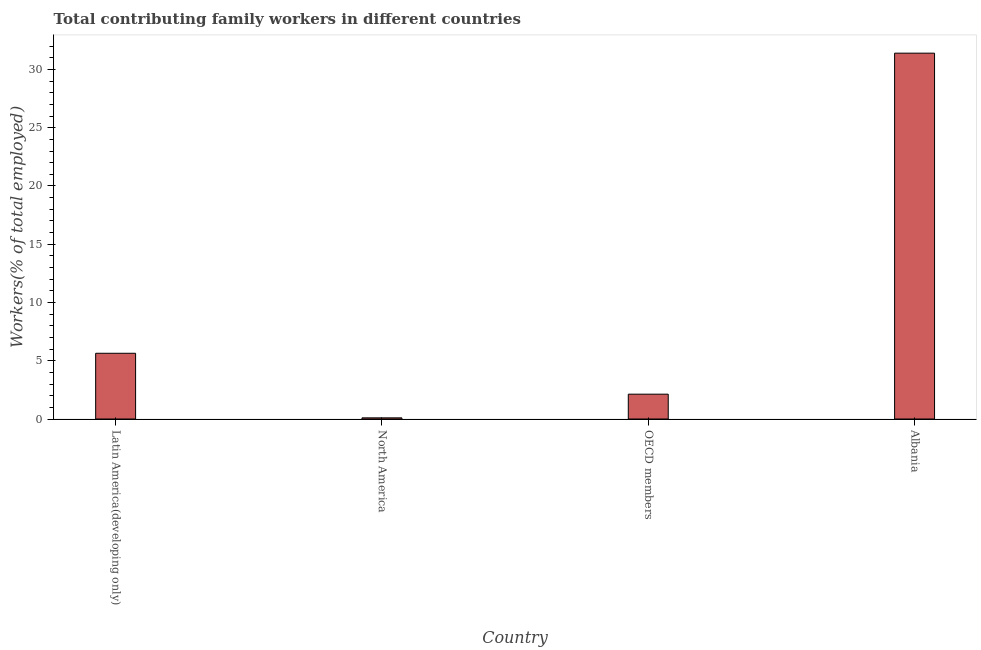What is the title of the graph?
Keep it short and to the point. Total contributing family workers in different countries. What is the label or title of the X-axis?
Provide a short and direct response. Country. What is the label or title of the Y-axis?
Give a very brief answer. Workers(% of total employed). What is the contributing family workers in Latin America(developing only)?
Offer a terse response. 5.64. Across all countries, what is the maximum contributing family workers?
Provide a short and direct response. 31.4. Across all countries, what is the minimum contributing family workers?
Your response must be concise. 0.1. In which country was the contributing family workers maximum?
Offer a very short reply. Albania. What is the sum of the contributing family workers?
Make the answer very short. 39.27. What is the difference between the contributing family workers in Latin America(developing only) and OECD members?
Your answer should be compact. 3.51. What is the average contributing family workers per country?
Offer a terse response. 9.82. What is the median contributing family workers?
Your answer should be very brief. 3.89. What is the ratio of the contributing family workers in North America to that in OECD members?
Provide a succinct answer. 0.05. Is the difference between the contributing family workers in Latin America(developing only) and OECD members greater than the difference between any two countries?
Ensure brevity in your answer.  No. What is the difference between the highest and the second highest contributing family workers?
Your answer should be very brief. 25.76. Is the sum of the contributing family workers in Albania and OECD members greater than the maximum contributing family workers across all countries?
Your answer should be very brief. Yes. What is the difference between the highest and the lowest contributing family workers?
Your answer should be very brief. 31.3. In how many countries, is the contributing family workers greater than the average contributing family workers taken over all countries?
Offer a very short reply. 1. Are the values on the major ticks of Y-axis written in scientific E-notation?
Make the answer very short. No. What is the Workers(% of total employed) in Latin America(developing only)?
Your answer should be very brief. 5.64. What is the Workers(% of total employed) of North America?
Ensure brevity in your answer.  0.1. What is the Workers(% of total employed) of OECD members?
Provide a succinct answer. 2.13. What is the Workers(% of total employed) in Albania?
Give a very brief answer. 31.4. What is the difference between the Workers(% of total employed) in Latin America(developing only) and North America?
Your answer should be very brief. 5.54. What is the difference between the Workers(% of total employed) in Latin America(developing only) and OECD members?
Offer a terse response. 3.51. What is the difference between the Workers(% of total employed) in Latin America(developing only) and Albania?
Offer a very short reply. -25.76. What is the difference between the Workers(% of total employed) in North America and OECD members?
Offer a terse response. -2.03. What is the difference between the Workers(% of total employed) in North America and Albania?
Your answer should be compact. -31.3. What is the difference between the Workers(% of total employed) in OECD members and Albania?
Your answer should be very brief. -29.27. What is the ratio of the Workers(% of total employed) in Latin America(developing only) to that in North America?
Your answer should be very brief. 56.42. What is the ratio of the Workers(% of total employed) in Latin America(developing only) to that in OECD members?
Your response must be concise. 2.65. What is the ratio of the Workers(% of total employed) in Latin America(developing only) to that in Albania?
Provide a short and direct response. 0.18. What is the ratio of the Workers(% of total employed) in North America to that in OECD members?
Offer a terse response. 0.05. What is the ratio of the Workers(% of total employed) in North America to that in Albania?
Give a very brief answer. 0. What is the ratio of the Workers(% of total employed) in OECD members to that in Albania?
Make the answer very short. 0.07. 